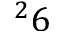Convert formula to latex. <formula><loc_0><loc_0><loc_500><loc_500>^ { 2 } 6</formula> 